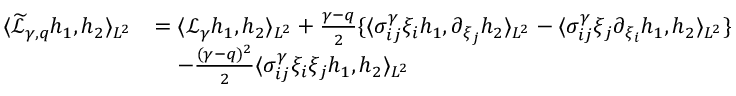<formula> <loc_0><loc_0><loc_500><loc_500>\begin{array} { r l } { \langle \widetilde { \mathcal { L } } _ { \gamma , q } h _ { 1 } , h _ { 2 } \rangle _ { L ^ { 2 } } } & { = \langle \mathcal { L } _ { \gamma } h _ { 1 } , h _ { 2 } \rangle _ { L ^ { 2 } } + \frac { \gamma - q } { 2 } \{ \langle \sigma _ { i j } ^ { \gamma } \xi _ { i } h _ { 1 } , \partial _ { \xi _ { j } } h _ { 2 } \rangle _ { L ^ { 2 } } - \langle \sigma _ { i j } ^ { \gamma } \xi _ { j } \partial _ { \xi _ { i } } h _ { 1 } , h _ { 2 } \rangle _ { L ^ { 2 } } \} } \\ & { \quad - \frac { ( \gamma - q ) ^ { 2 } } { 2 } \langle \sigma _ { i j } ^ { \gamma } \xi _ { i } \xi _ { j } h _ { 1 } , h _ { 2 } \rangle _ { L ^ { 2 } } } \end{array}</formula> 